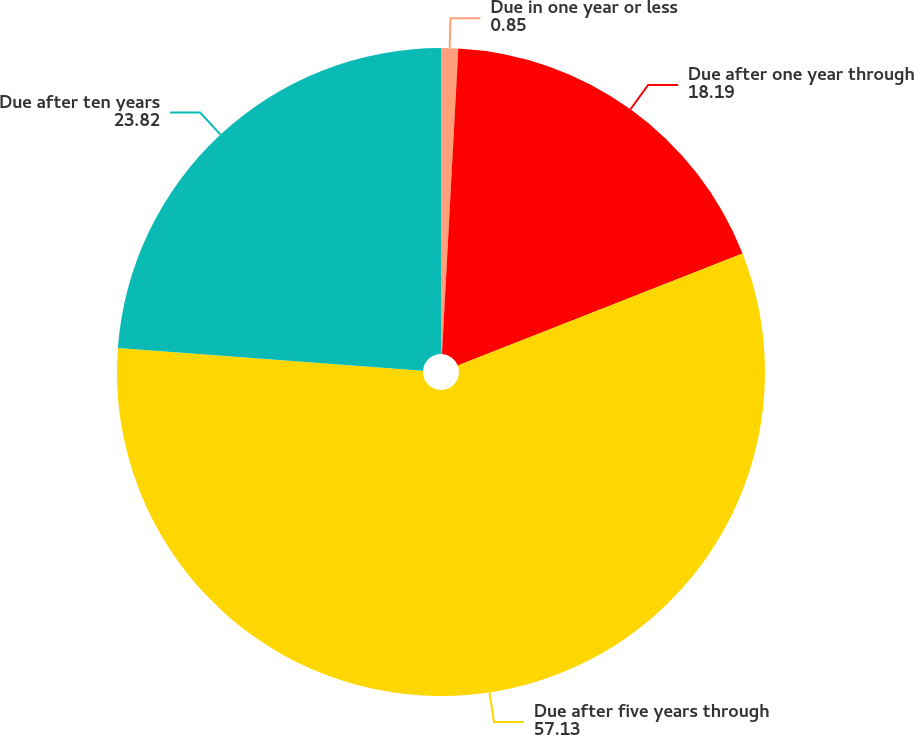Convert chart. <chart><loc_0><loc_0><loc_500><loc_500><pie_chart><fcel>Due in one year or less<fcel>Due after one year through<fcel>Due after five years through<fcel>Due after ten years<nl><fcel>0.85%<fcel>18.19%<fcel>57.13%<fcel>23.82%<nl></chart> 